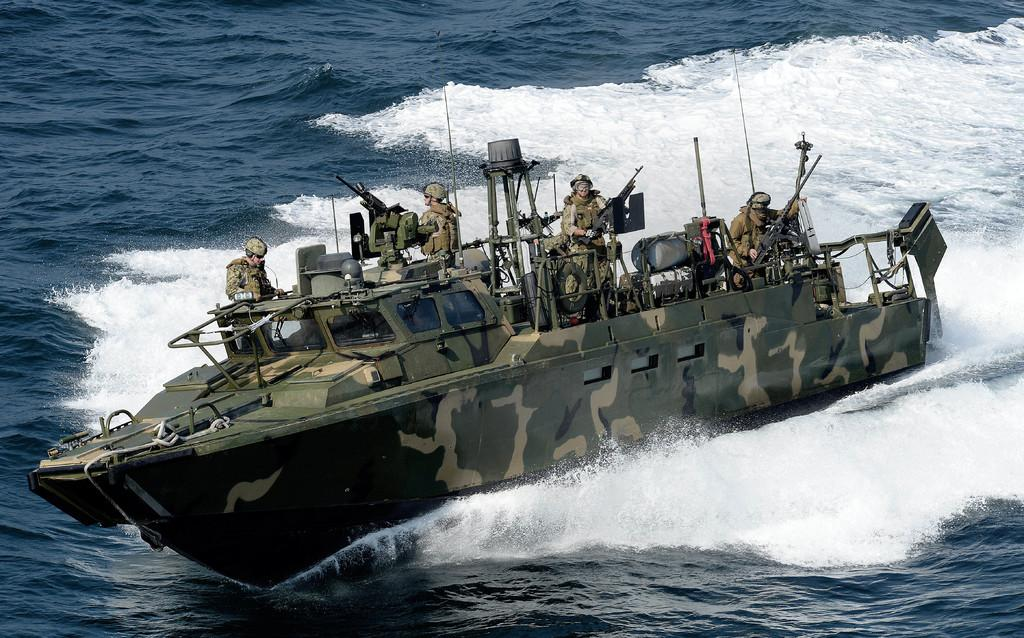What is the main setting of the image? The main setting of the image is water. What type of vehicle is in the water? There is a military boat in the image. Who is present in the image? Military people are present in the image. What are the military people holding? The military people are holding weapons. What can be seen inside the boat? There are unspecified things inside the boat. What type of dinner is being served on the boat in the image? There is no dinner being served in the image; the focus is on the military boat and personnel. 